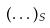Convert formula to latex. <formula><loc_0><loc_0><loc_500><loc_500>( \dots ) _ { S }</formula> 